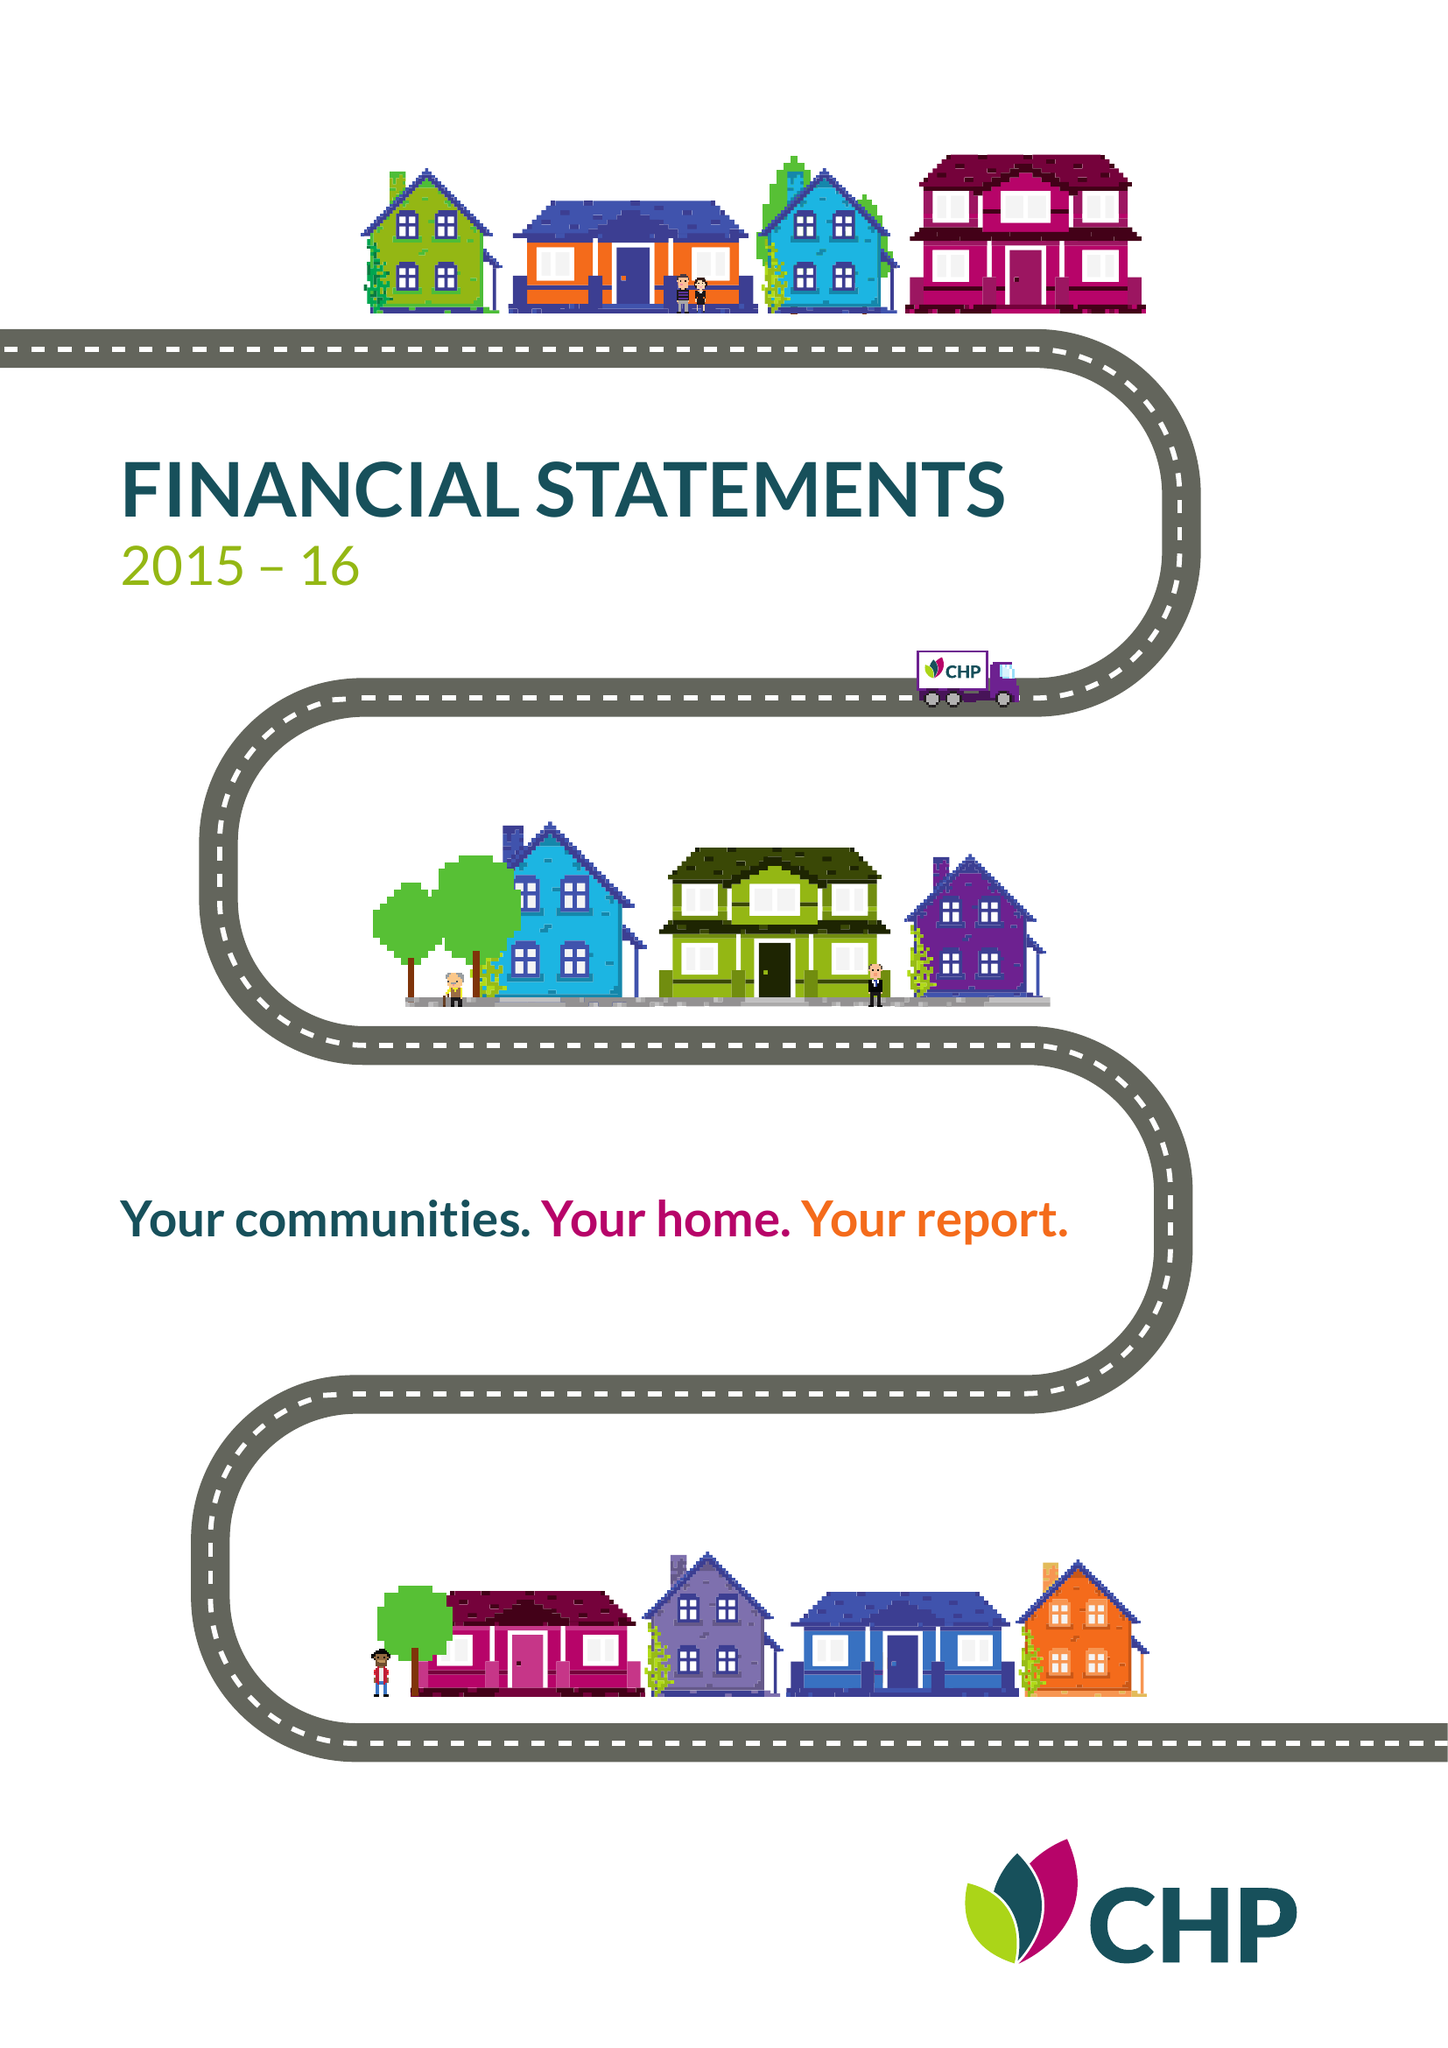What is the value for the address__street_line?
Answer the question using a single word or phrase. None 